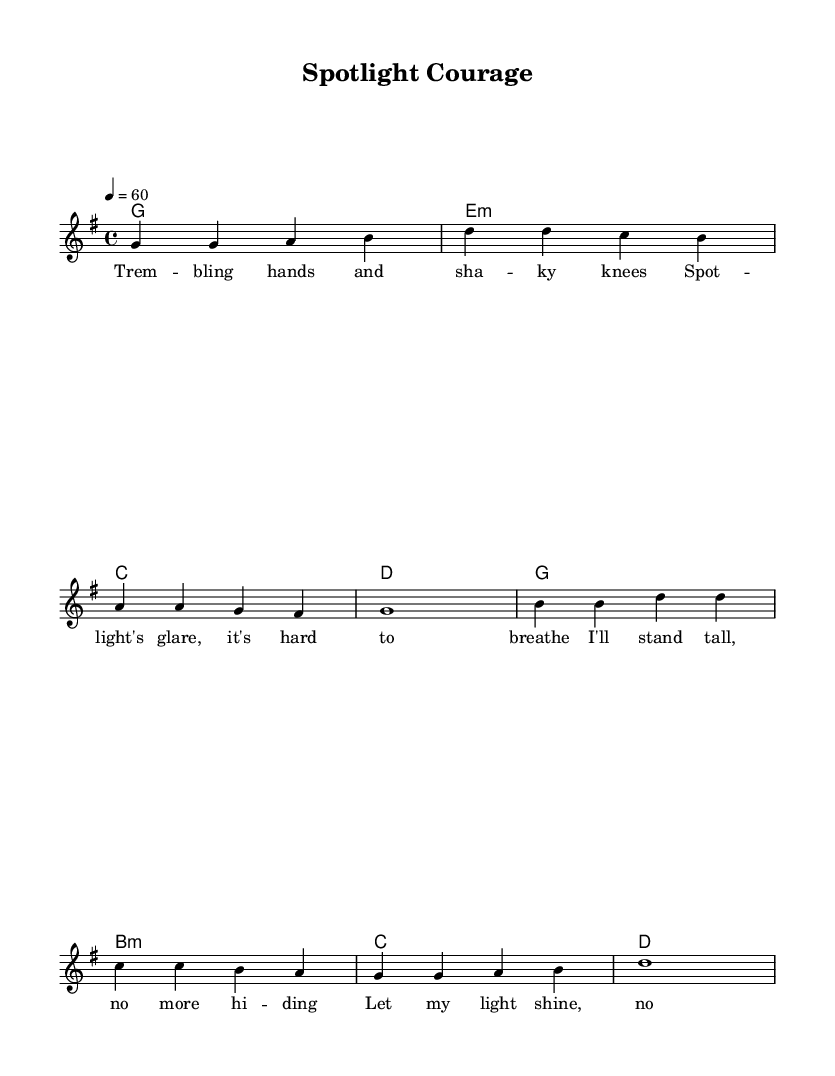What is the key signature of this music? The key signature is indicated at the beginning of the sheet music, showing one sharp, which corresponds to G major.
Answer: G major What is the time signature of this music? The time signature is found at the beginning of the sheet music, showing four beats per measure.
Answer: 4/4 What is the tempo marking for this piece? The tempo is given in beats per minute at the beginning of the music, showing a marking of quarter note equals sixty beats per minute.
Answer: 60 How many measures are in the verse section? By counting the groups of notes and bars in the verse, we see four measures are present, which comprise the complete section.
Answer: 4 Which chords are used in the chorus? Analyzing the chord changes in the chorus section reveals the specific progression used: G, B minor, C, D.
Answer: G, B minor, C, D What thematic element is explored in the lyrics? The lyrics express a struggle with stage fright and the decision to confront it, leading to themes of confidence and self-acceptance.
Answer: Overcoming stage fright How does the melody relate to the lyrics in the chorus? Observing the melody and harmonies shows that they are uplifting and resonate with the assertive and confident words of the chorus, supporting the message of empowerment.
Answer: Uplifting and confident 